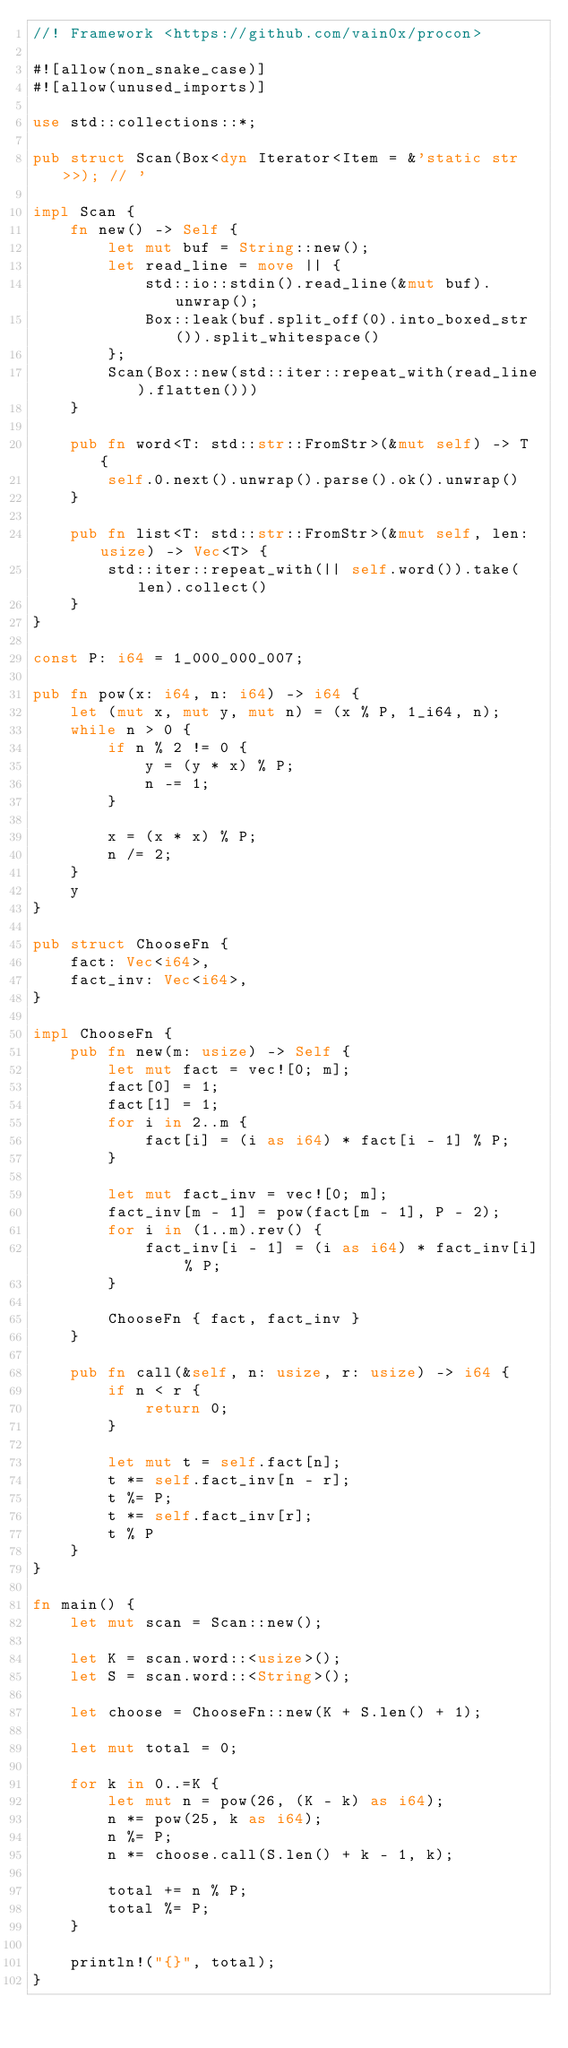<code> <loc_0><loc_0><loc_500><loc_500><_Rust_>//! Framework <https://github.com/vain0x/procon>

#![allow(non_snake_case)]
#![allow(unused_imports)]

use std::collections::*;

pub struct Scan(Box<dyn Iterator<Item = &'static str>>); // '

impl Scan {
    fn new() -> Self {
        let mut buf = String::new();
        let read_line = move || {
            std::io::stdin().read_line(&mut buf).unwrap();
            Box::leak(buf.split_off(0).into_boxed_str()).split_whitespace()
        };
        Scan(Box::new(std::iter::repeat_with(read_line).flatten()))
    }

    pub fn word<T: std::str::FromStr>(&mut self) -> T {
        self.0.next().unwrap().parse().ok().unwrap()
    }

    pub fn list<T: std::str::FromStr>(&mut self, len: usize) -> Vec<T> {
        std::iter::repeat_with(|| self.word()).take(len).collect()
    }
}

const P: i64 = 1_000_000_007;

pub fn pow(x: i64, n: i64) -> i64 {
    let (mut x, mut y, mut n) = (x % P, 1_i64, n);
    while n > 0 {
        if n % 2 != 0 {
            y = (y * x) % P;
            n -= 1;
        }

        x = (x * x) % P;
        n /= 2;
    }
    y
}

pub struct ChooseFn {
    fact: Vec<i64>,
    fact_inv: Vec<i64>,
}

impl ChooseFn {
    pub fn new(m: usize) -> Self {
        let mut fact = vec![0; m];
        fact[0] = 1;
        fact[1] = 1;
        for i in 2..m {
            fact[i] = (i as i64) * fact[i - 1] % P;
        }

        let mut fact_inv = vec![0; m];
        fact_inv[m - 1] = pow(fact[m - 1], P - 2);
        for i in (1..m).rev() {
            fact_inv[i - 1] = (i as i64) * fact_inv[i] % P;
        }

        ChooseFn { fact, fact_inv }
    }

    pub fn call(&self, n: usize, r: usize) -> i64 {
        if n < r {
            return 0;
        }

        let mut t = self.fact[n];
        t *= self.fact_inv[n - r];
        t %= P;
        t *= self.fact_inv[r];
        t % P
    }
}

fn main() {
    let mut scan = Scan::new();

    let K = scan.word::<usize>();
    let S = scan.word::<String>();

    let choose = ChooseFn::new(K + S.len() + 1);

    let mut total = 0;

    for k in 0..=K {
        let mut n = pow(26, (K - k) as i64);
        n *= pow(25, k as i64);
        n %= P;
        n *= choose.call(S.len() + k - 1, k);

        total += n % P;
        total %= P;
    }

    println!("{}", total);
}
</code> 